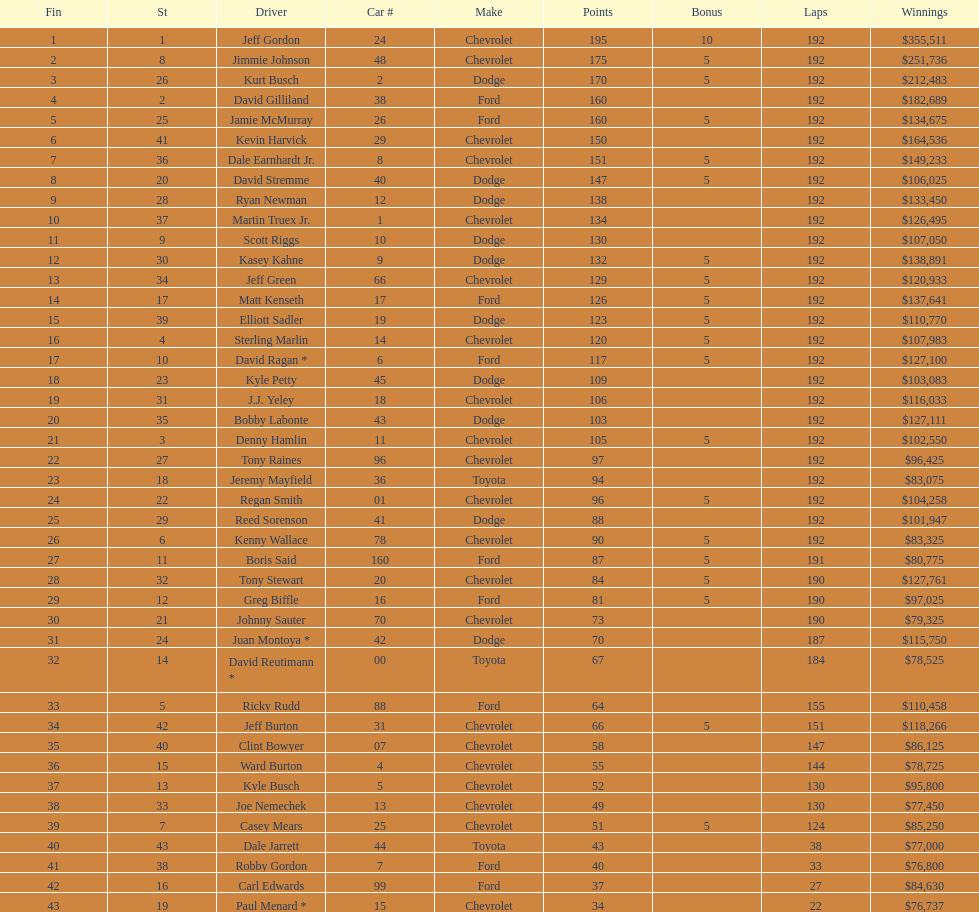Out of the 43 listed race car drivers, how many were driving toyotas? 3. Parse the full table. {'header': ['Fin', 'St', 'Driver', 'Car #', 'Make', 'Points', 'Bonus', 'Laps', 'Winnings'], 'rows': [['1', '1', 'Jeff Gordon', '24', 'Chevrolet', '195', '10', '192', '$355,511'], ['2', '8', 'Jimmie Johnson', '48', 'Chevrolet', '175', '5', '192', '$251,736'], ['3', '26', 'Kurt Busch', '2', 'Dodge', '170', '5', '192', '$212,483'], ['4', '2', 'David Gilliland', '38', 'Ford', '160', '', '192', '$182,689'], ['5', '25', 'Jamie McMurray', '26', 'Ford', '160', '5', '192', '$134,675'], ['6', '41', 'Kevin Harvick', '29', 'Chevrolet', '150', '', '192', '$164,536'], ['7', '36', 'Dale Earnhardt Jr.', '8', 'Chevrolet', '151', '5', '192', '$149,233'], ['8', '20', 'David Stremme', '40', 'Dodge', '147', '5', '192', '$106,025'], ['9', '28', 'Ryan Newman', '12', 'Dodge', '138', '', '192', '$133,450'], ['10', '37', 'Martin Truex Jr.', '1', 'Chevrolet', '134', '', '192', '$126,495'], ['11', '9', 'Scott Riggs', '10', 'Dodge', '130', '', '192', '$107,050'], ['12', '30', 'Kasey Kahne', '9', 'Dodge', '132', '5', '192', '$138,891'], ['13', '34', 'Jeff Green', '66', 'Chevrolet', '129', '5', '192', '$120,933'], ['14', '17', 'Matt Kenseth', '17', 'Ford', '126', '5', '192', '$137,641'], ['15', '39', 'Elliott Sadler', '19', 'Dodge', '123', '5', '192', '$110,770'], ['16', '4', 'Sterling Marlin', '14', 'Chevrolet', '120', '5', '192', '$107,983'], ['17', '10', 'David Ragan *', '6', 'Ford', '117', '5', '192', '$127,100'], ['18', '23', 'Kyle Petty', '45', 'Dodge', '109', '', '192', '$103,083'], ['19', '31', 'J.J. Yeley', '18', 'Chevrolet', '106', '', '192', '$116,033'], ['20', '35', 'Bobby Labonte', '43', 'Dodge', '103', '', '192', '$127,111'], ['21', '3', 'Denny Hamlin', '11', 'Chevrolet', '105', '5', '192', '$102,550'], ['22', '27', 'Tony Raines', '96', 'Chevrolet', '97', '', '192', '$96,425'], ['23', '18', 'Jeremy Mayfield', '36', 'Toyota', '94', '', '192', '$83,075'], ['24', '22', 'Regan Smith', '01', 'Chevrolet', '96', '5', '192', '$104,258'], ['25', '29', 'Reed Sorenson', '41', 'Dodge', '88', '', '192', '$101,947'], ['26', '6', 'Kenny Wallace', '78', 'Chevrolet', '90', '5', '192', '$83,325'], ['27', '11', 'Boris Said', '160', 'Ford', '87', '5', '191', '$80,775'], ['28', '32', 'Tony Stewart', '20', 'Chevrolet', '84', '5', '190', '$127,761'], ['29', '12', 'Greg Biffle', '16', 'Ford', '81', '5', '190', '$97,025'], ['30', '21', 'Johnny Sauter', '70', 'Chevrolet', '73', '', '190', '$79,325'], ['31', '24', 'Juan Montoya *', '42', 'Dodge', '70', '', '187', '$115,750'], ['32', '14', 'David Reutimann *', '00', 'Toyota', '67', '', '184', '$78,525'], ['33', '5', 'Ricky Rudd', '88', 'Ford', '64', '', '155', '$110,458'], ['34', '42', 'Jeff Burton', '31', 'Chevrolet', '66', '5', '151', '$118,266'], ['35', '40', 'Clint Bowyer', '07', 'Chevrolet', '58', '', '147', '$86,125'], ['36', '15', 'Ward Burton', '4', 'Chevrolet', '55', '', '144', '$78,725'], ['37', '13', 'Kyle Busch', '5', 'Chevrolet', '52', '', '130', '$95,800'], ['38', '33', 'Joe Nemechek', '13', 'Chevrolet', '49', '', '130', '$77,450'], ['39', '7', 'Casey Mears', '25', 'Chevrolet', '51', '5', '124', '$85,250'], ['40', '43', 'Dale Jarrett', '44', 'Toyota', '43', '', '38', '$77,000'], ['41', '38', 'Robby Gordon', '7', 'Ford', '40', '', '33', '$76,800'], ['42', '16', 'Carl Edwards', '99', 'Ford', '37', '', '27', '$84,630'], ['43', '19', 'Paul Menard *', '15', 'Chevrolet', '34', '', '22', '$76,737']]} 